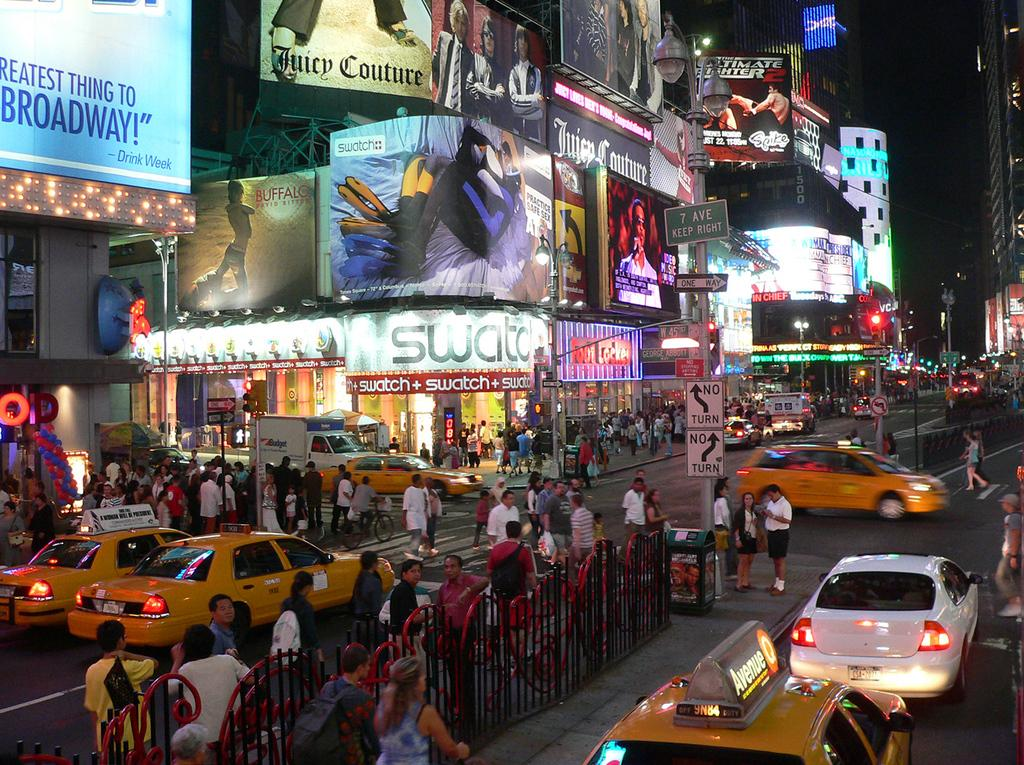<image>
Describe the image concisely. A busy intersection with cars and civilians crossing, a Swatch store can be seen on the corner in white. 